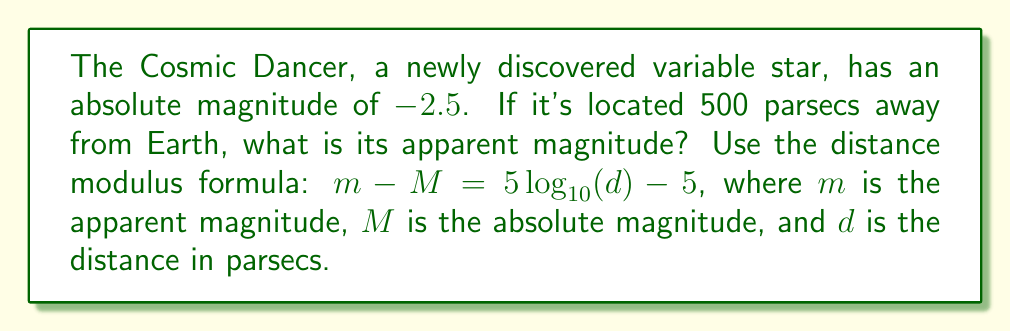What is the answer to this math problem? Let's approach this step-by-step:

1) We are given:
   - Absolute magnitude (M) = -2.5
   - Distance (d) = 500 parsecs

2) We need to find the apparent magnitude (m) using the distance modulus formula:

   $$m - M = 5 \log_{10}(d) - 5$$

3) Let's substitute the known values:

   $$m - (-2.5) = 5 \log_{10}(500) - 5$$

4) Simplify the left side:

   $$m + 2.5 = 5 \log_{10}(500) - 5$$

5) Calculate the right side:
   $$5 \log_{10}(500) - 5 = 5 * 2.69897 - 5 = 13.49485 - 5 = 8.49485$$

6) Our equation is now:

   $$m + 2.5 = 8.49485$$

7) Solve for m:

   $$m = 8.49485 - 2.5 = 5.99485$$

8) Round to two decimal places:

   $$m \approx 5.99$$
Answer: 5.99 